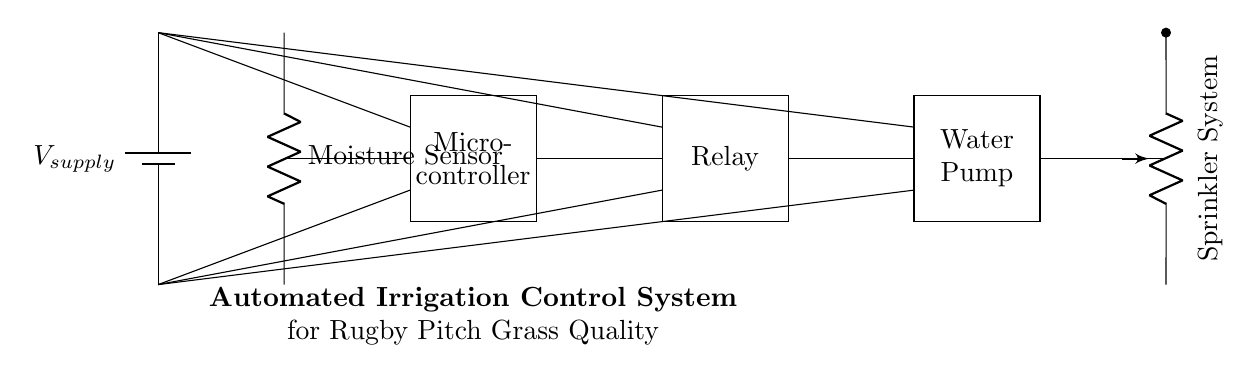What component detects soil moisture? The moisture sensor is the component that measures the soil's moisture levels in this circuit. It is clearly labeled and positioned at the top left in the diagram.
Answer: Moisture Sensor What powers the irrigation system? The power supply, indicated as V_supply in the circuit, is responsible for providing the necessary voltage to the entire irrigation control system. It is represented as a battery symbol.
Answer: V_supply Which component controls the water pump? The relay controls the water pump by acting as a switch that is activated by the microcontroller. The connection from the microcontroller to the relay indicates this control mechanism.
Answer: Relay How many main components are in the circuit? The circuit contains four main components: the moisture sensor, microcontroller, relay, and water pump. These components are essential for the functioning of the automated irrigation system.
Answer: Four What is the function of the microcontroller? The microcontroller interprets data from the moisture sensor and decides when to activate the relay, which controls the water pump. This processing makes it the brain of the circuit for automation purposes.
Answer: Control logic What does the sprinkler system do? The sprinkler system distributes water to the rugby pitch, ensuring the grass quality is maintained. It is indicated as a load connected at the end of the circuit.
Answer: Distributes water How is the moisture sensor connected in the circuit? The moisture sensor is connected in parallel with the power supply, with a direct line to the microcontroller, allowing it to send data to the microcontroller for processing.
Answer: Directly to microcontroller 